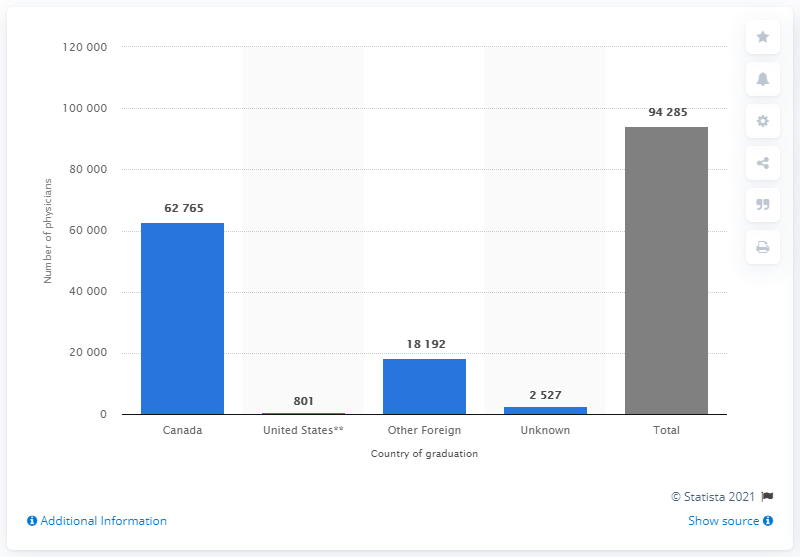Outline some significant characteristics in this image. In the United States, 801 physicians graduated. 